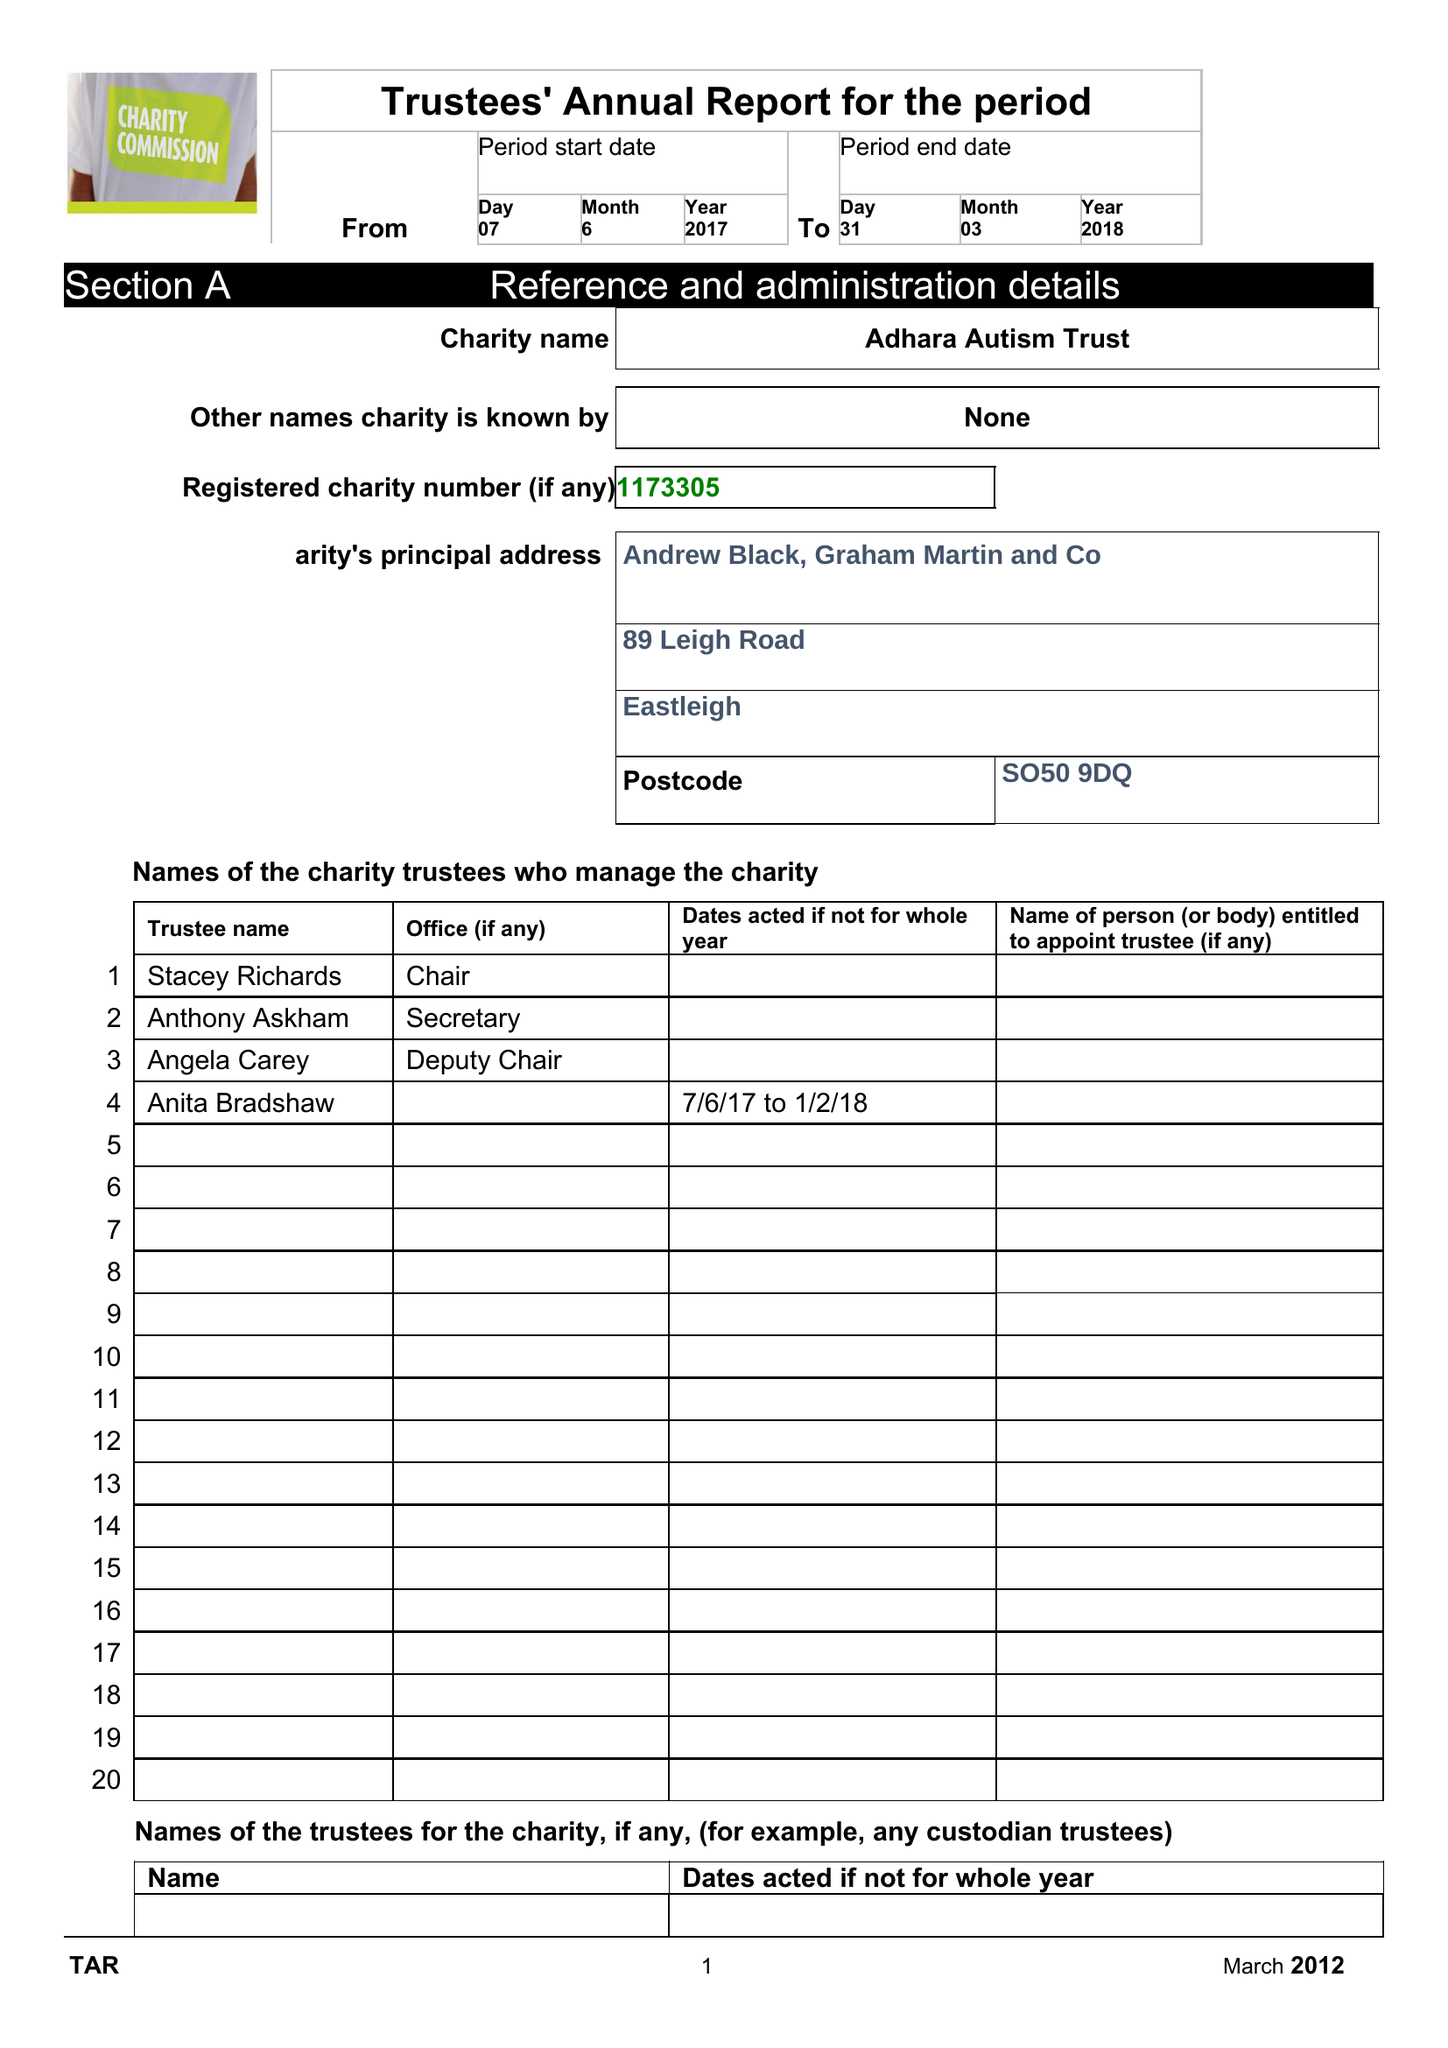What is the value for the charity_name?
Answer the question using a single word or phrase. Adhara Autism Trust 